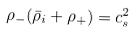<formula> <loc_0><loc_0><loc_500><loc_500>\rho _ { - } ( \bar { \rho } _ { i } + \rho _ { + } ) = c _ { s } ^ { 2 }</formula> 